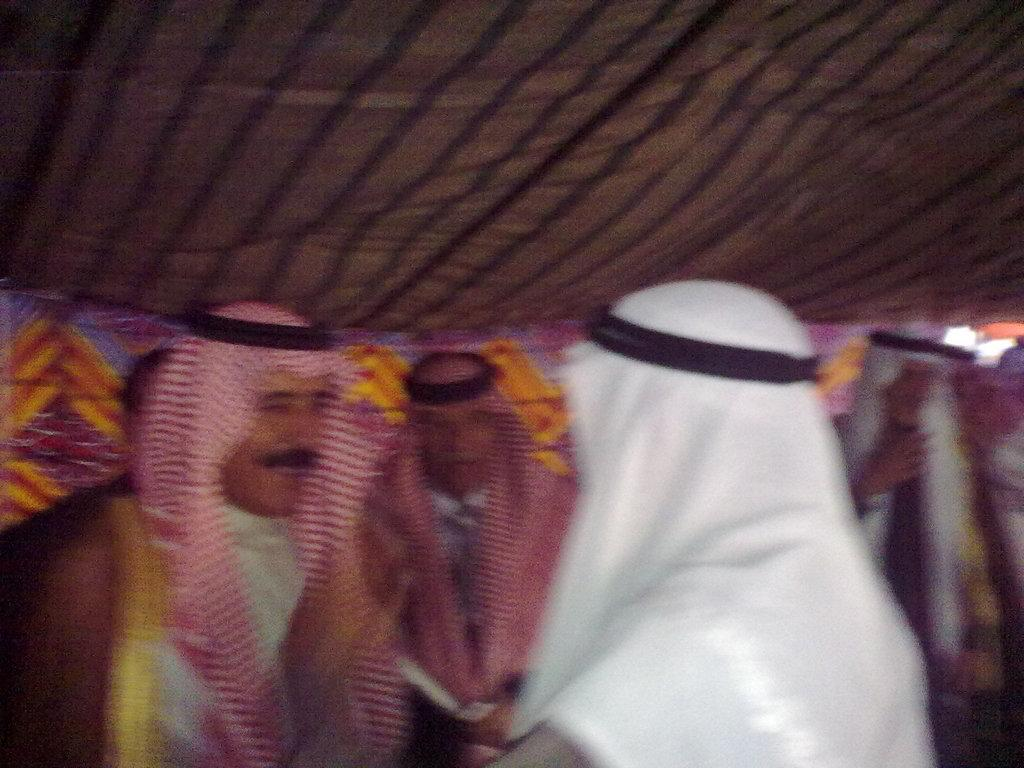Who or what can be seen in the image? There are people in the image. Where are the people located in the image? The people are in the center of the image. What is the setting or environment of the people in the image? The people are inside a tent. What type of button can be seen on the tent in the image? There is no button visible on the tent in the image. What kind of bushes are surrounding the tent in the image? There are no bushes present in the image; the people are inside a tent. 